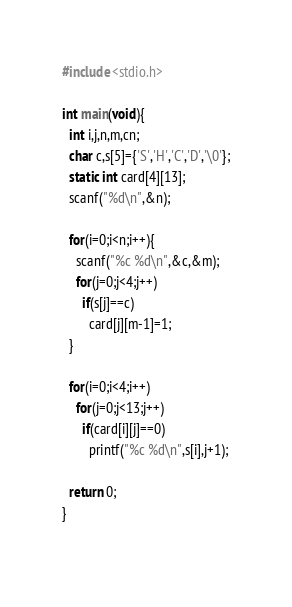<code> <loc_0><loc_0><loc_500><loc_500><_C_>#include <stdio.h>

int main(void){
  int i,j,n,m,cn;
  char c,s[5]={'S','H','C','D','\0'};
  static int card[4][13];
  scanf("%d\n",&n);

  for(i=0;i<n;i++){
    scanf("%c %d\n",&c,&m);
    for(j=0;j<4;j++)
      if(s[j]==c)
        card[j][m-1]=1;
  }
  
  for(i=0;i<4;i++)
    for(j=0;j<13;j++)
      if(card[i][j]==0)
        printf("%c %d\n",s[i],j+1);

  return 0;
}
 
</code> 